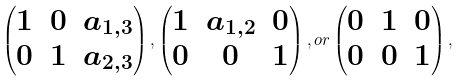<formula> <loc_0><loc_0><loc_500><loc_500>\begin{pmatrix} 1 & 0 & a _ { 1 , 3 } \\ 0 & 1 & a _ { 2 , 3 } \end{pmatrix} , \begin{pmatrix} 1 & a _ { 1 , 2 } & 0 \\ 0 & 0 & 1 \end{pmatrix} , o r \begin{pmatrix} 0 & 1 & 0 \\ 0 & 0 & 1 \end{pmatrix} ,</formula> 